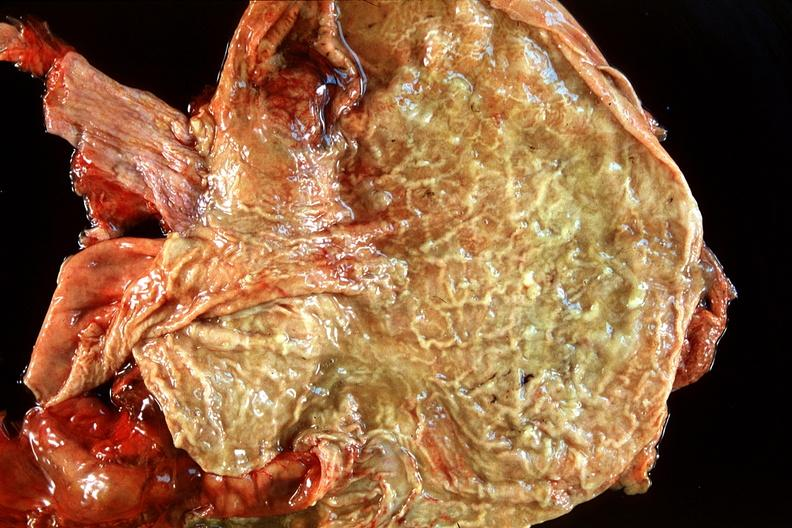what is present?
Answer the question using a single word or phrase. Gastrointestinal 